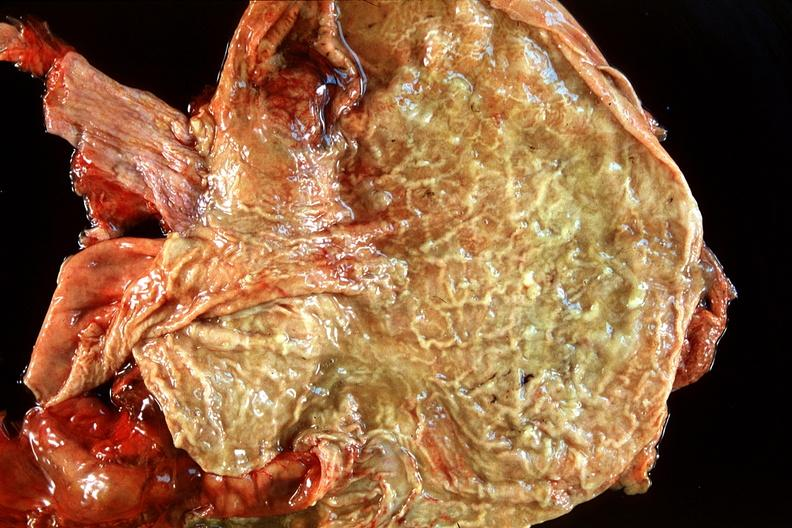what is present?
Answer the question using a single word or phrase. Gastrointestinal 